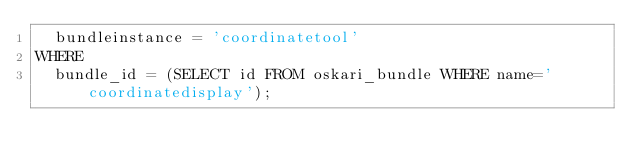<code> <loc_0><loc_0><loc_500><loc_500><_SQL_>	bundleinstance = 'coordinatetool'
WHERE
	bundle_id = (SELECT id FROM oskari_bundle WHERE name='coordinatedisplay');</code> 